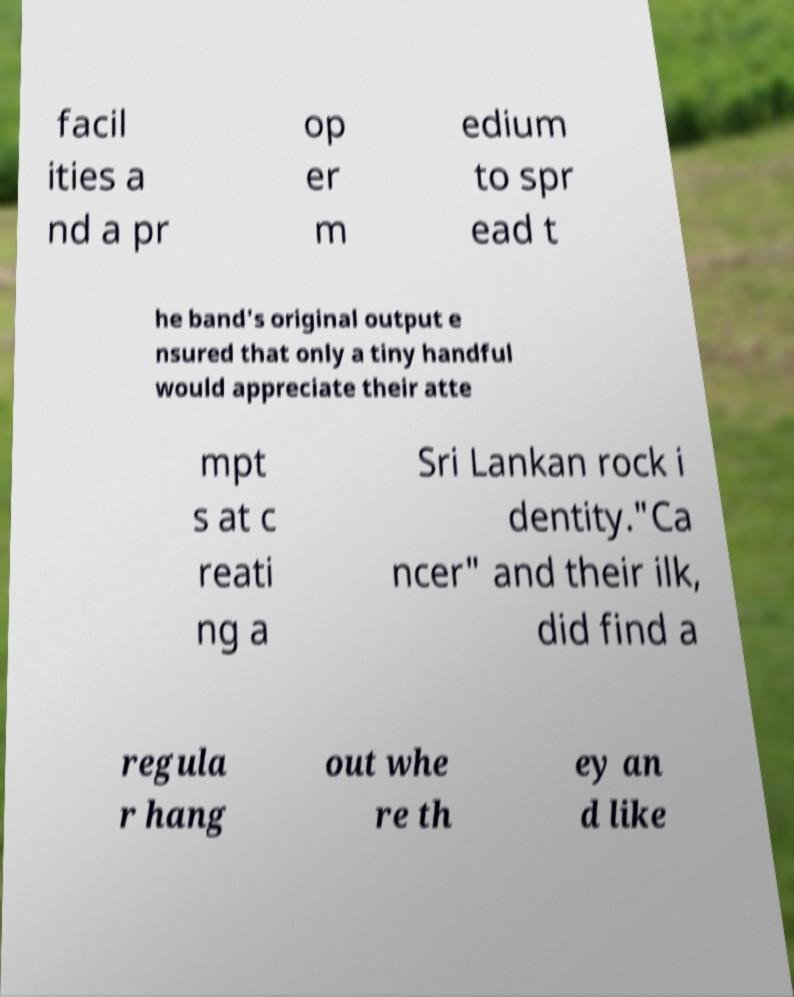Please identify and transcribe the text found in this image. facil ities a nd a pr op er m edium to spr ead t he band's original output e nsured that only a tiny handful would appreciate their atte mpt s at c reati ng a Sri Lankan rock i dentity."Ca ncer" and their ilk, did find a regula r hang out whe re th ey an d like 